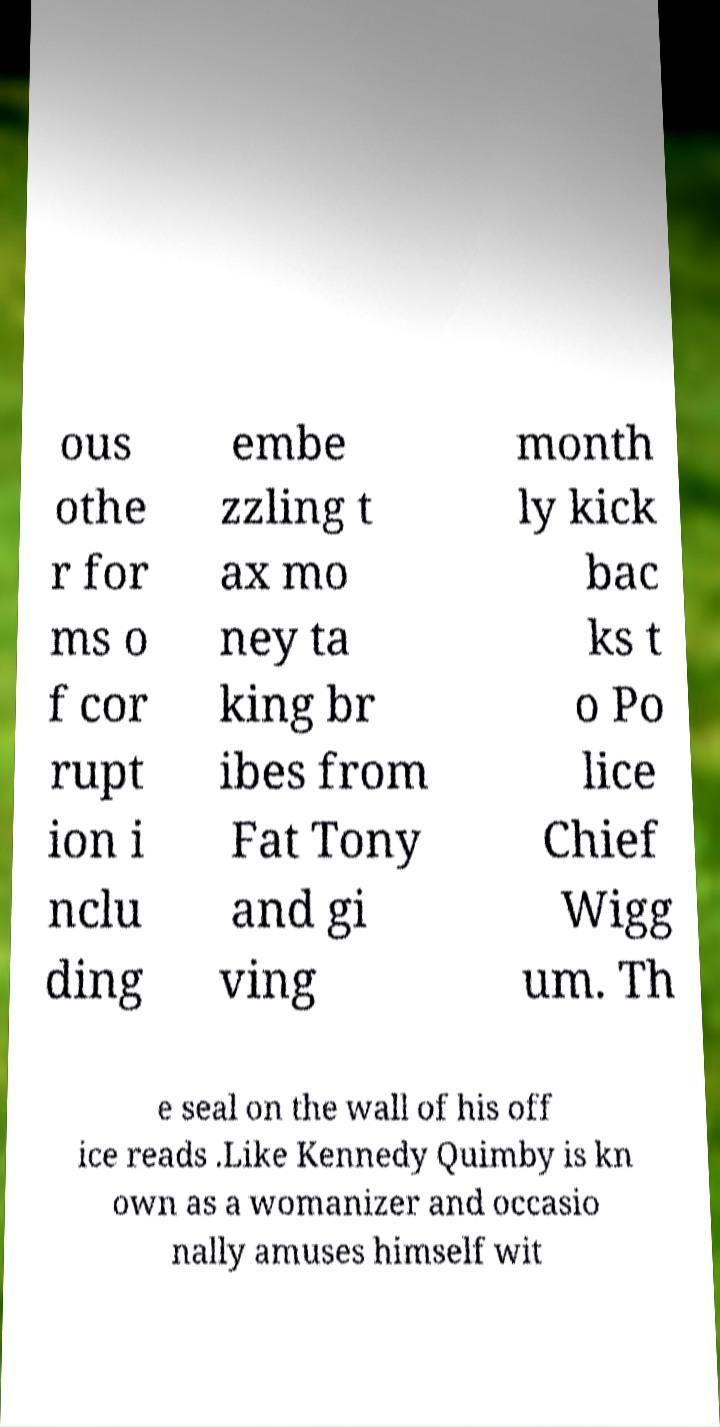Could you extract and type out the text from this image? ous othe r for ms o f cor rupt ion i nclu ding embe zzling t ax mo ney ta king br ibes from Fat Tony and gi ving month ly kick bac ks t o Po lice Chief Wigg um. Th e seal on the wall of his off ice reads .Like Kennedy Quimby is kn own as a womanizer and occasio nally amuses himself wit 